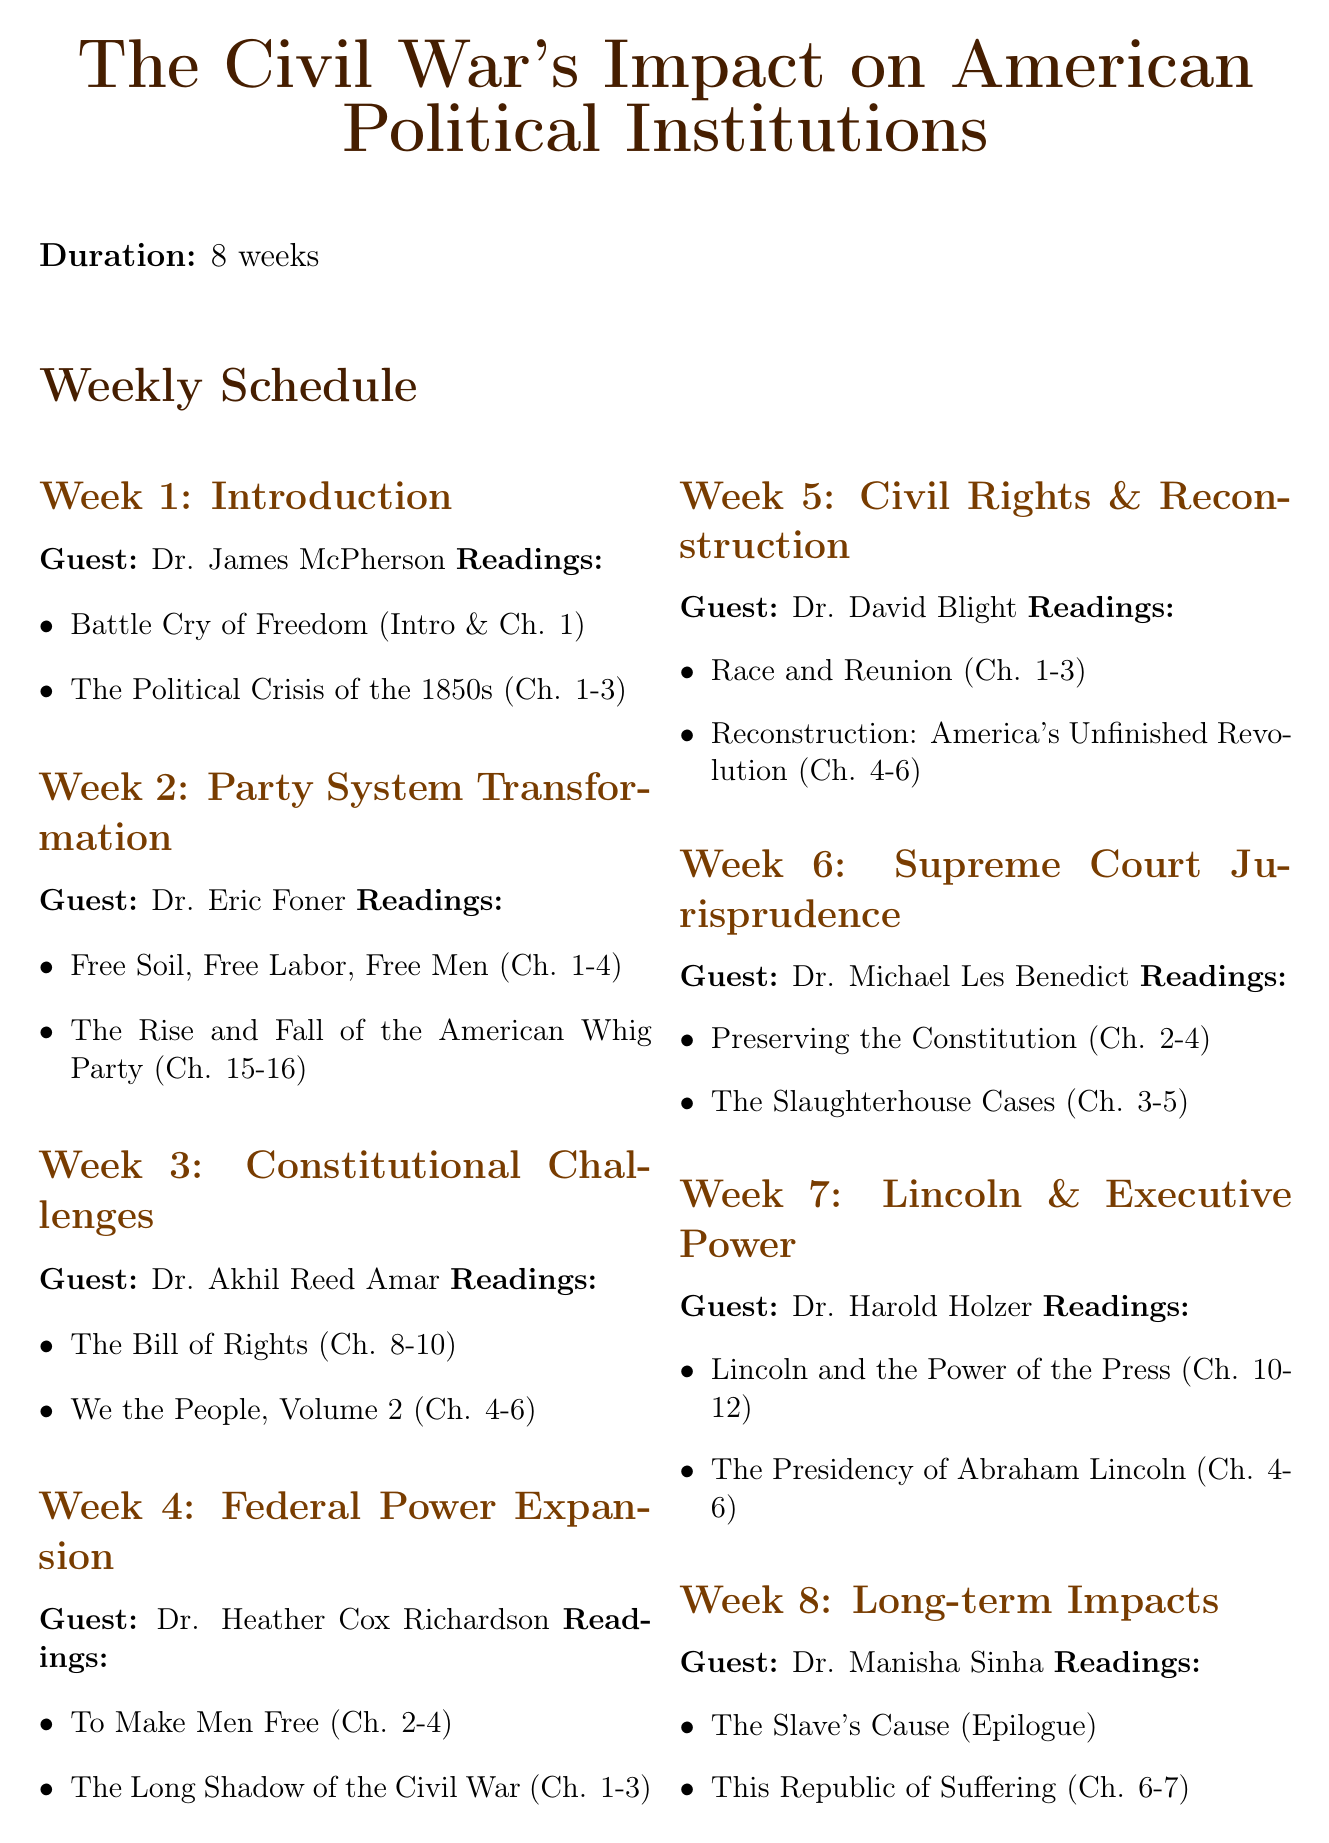What is the title of the seminar? The title is prominently displayed at the top of the document for clarity.
Answer: The Civil War's Impact on American Political Institutions How many weeks is the seminar scheduled for? The document specifies the duration of the seminar in the introduction.
Answer: 8 weeks Who is the guest speaker for Week 3? This information is included in the weekly schedule section of the document.
Answer: Dr. Akhil Reed Amar What is the required reading for Week 5? The document lists required readings for each week, providing specific titles and chapters.
Answer: Race and Reunion (Chapters 1-3) What type of final assignment is mentioned? The document details different types of assignments included in the seminar outline.
Answer: Final Research Project How many chapters of "Battle Cry of Freedom" are required in Week 1? The required readings specify which chapters need to be read for that week.
Answer: Introduction and Chapter 1 Who teaches the online course linked as an additional resource? The document identifies the instructor for the online course related to the seminar content.
Answer: Dr. Gary W. Gallagher What is the page count for the Midterm Paper assignment? The assignment descriptions include word counts for the papers required in the seminar.
Answer: 2500-word 